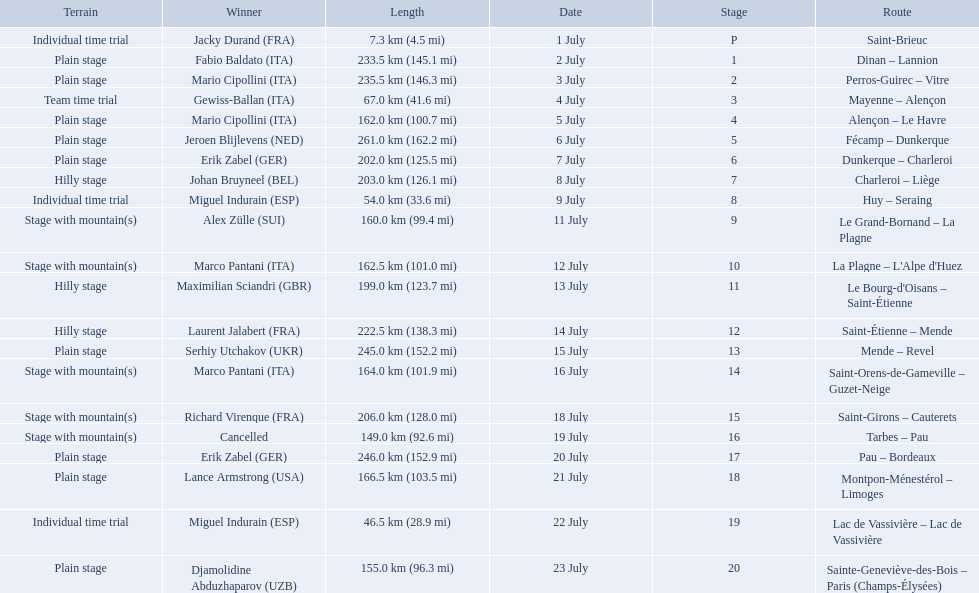What were the dates of the 1995 tour de france? 1 July, 2 July, 3 July, 4 July, 5 July, 6 July, 7 July, 8 July, 9 July, 11 July, 12 July, 13 July, 14 July, 15 July, 16 July, 18 July, 19 July, 20 July, 21 July, 22 July, 23 July. What was the length for july 8th? 203.0 km (126.1 mi). 